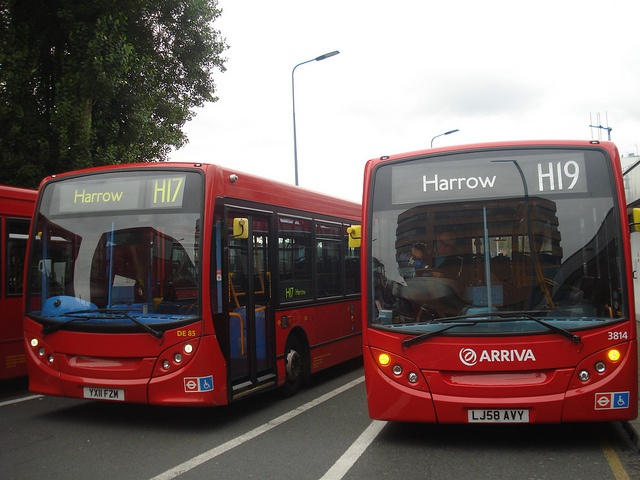Describe the objects in this image and their specific colors. I can see bus in black, maroon, and gray tones, bus in black, maroon, and gray tones, bus in black, maroon, and darkgray tones, and people in black and gray tones in this image. 